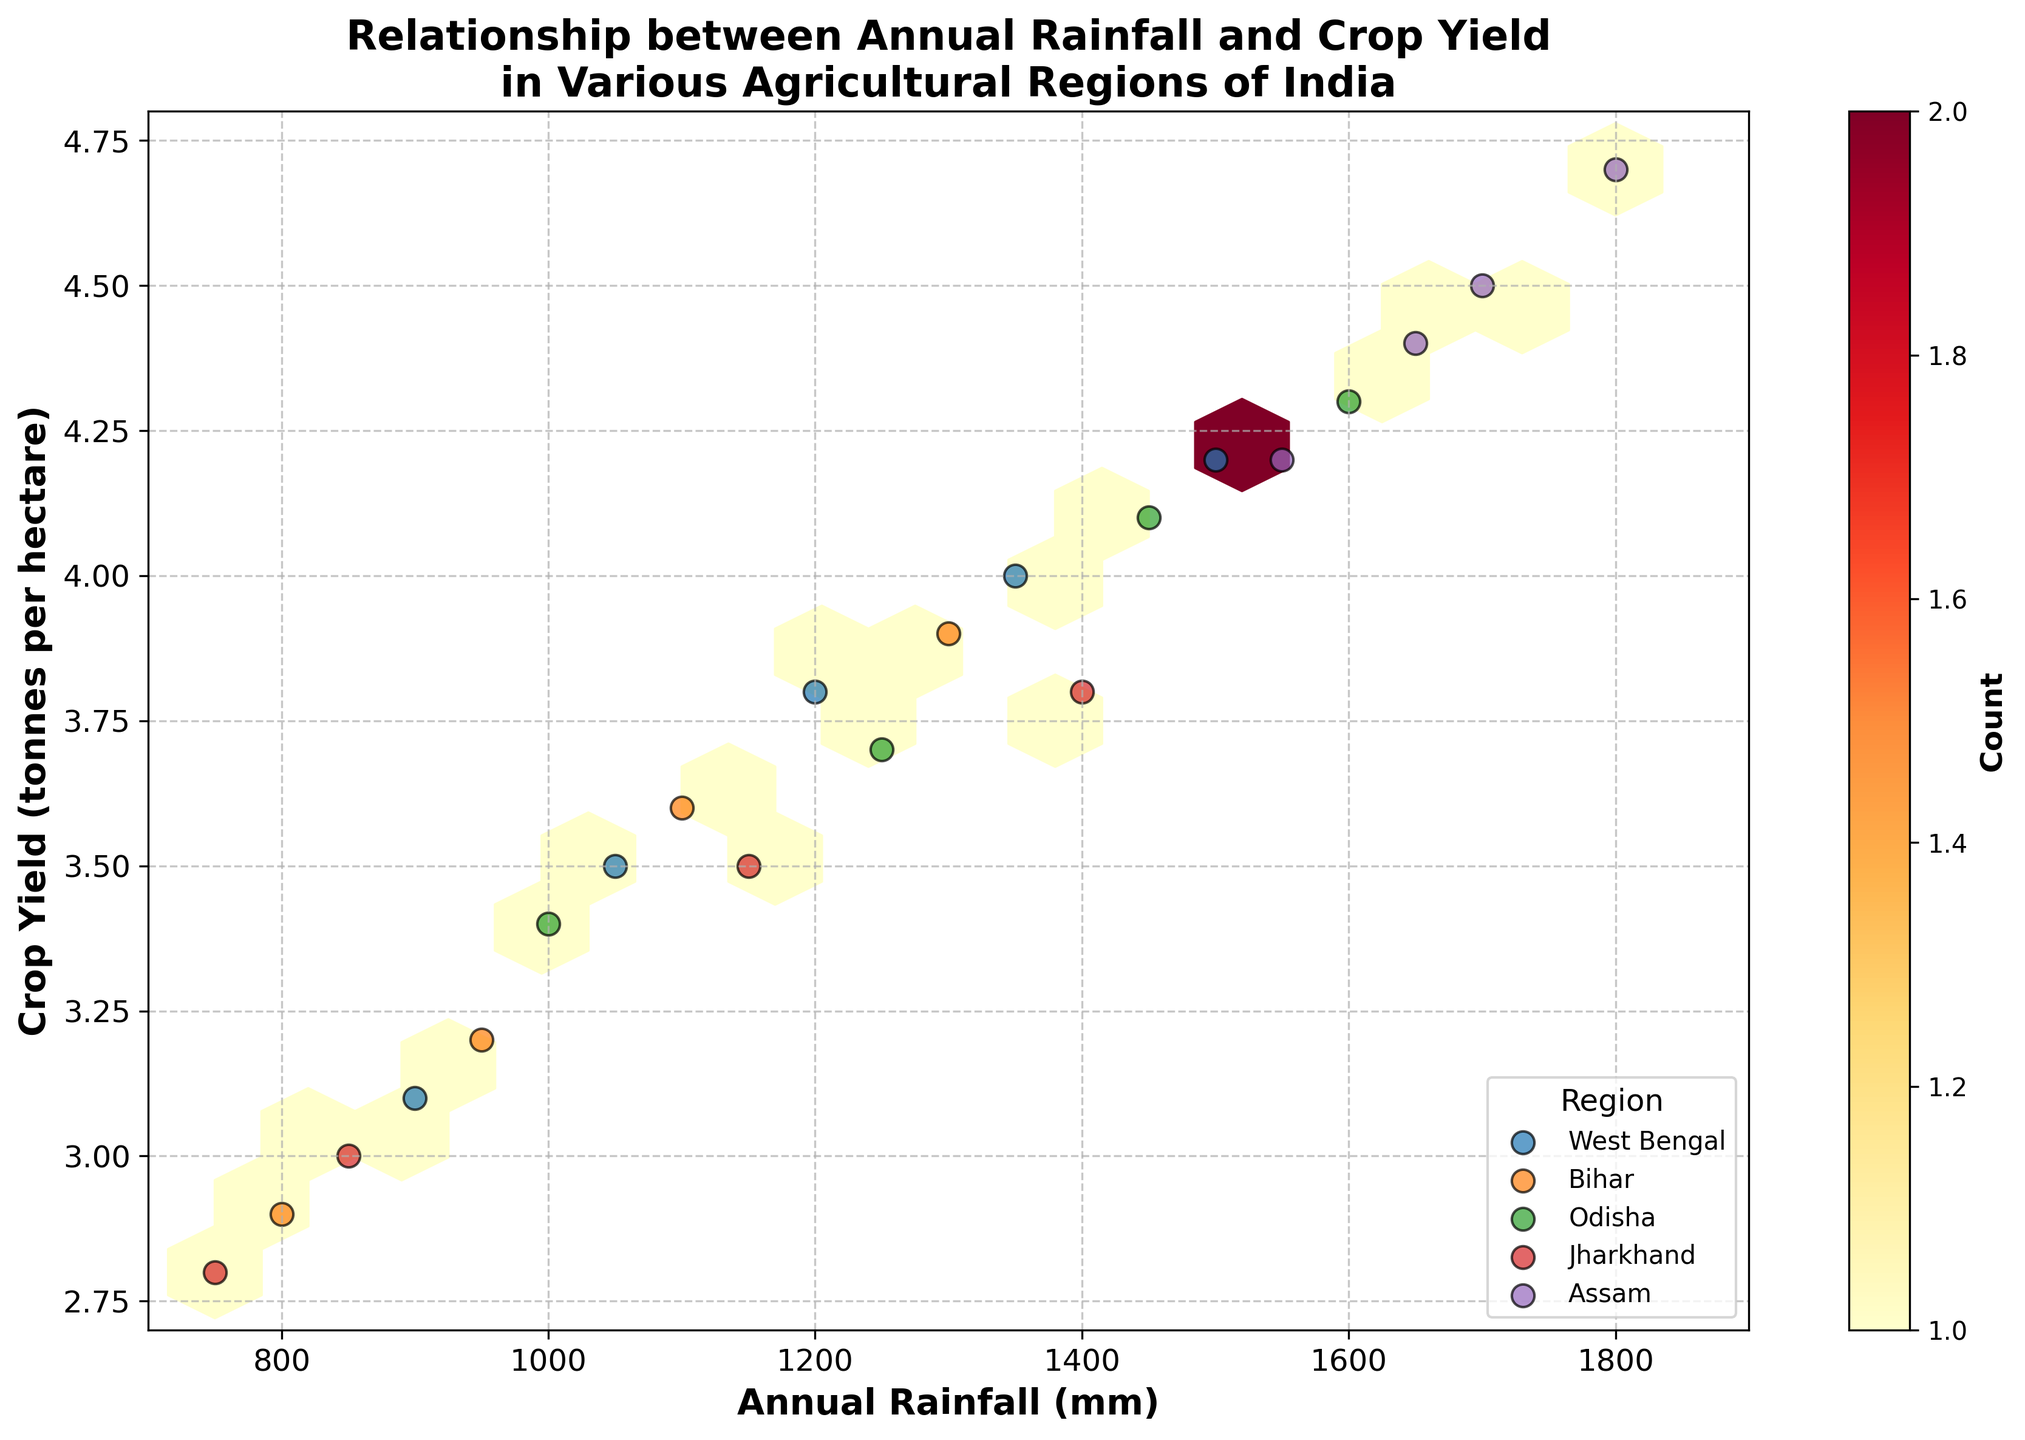What is the title of the plot? The title of the plot is displayed at the top in bold and large font. It summarizes the overall theme or subject of the plot.
Answer: Relationship between Annual Rainfall and Crop Yield in Various Agricultural Regions of India What does the color intensity represent in this plot? In a hexbin plot, the color intensity represents the density or count of data points within each hexagon. The legend indicates this with a color gradient changing from light to dark.
Answer: Count of data points What range of annual rainfall is covered in this plot? The x-axis of the plot represents the annual rainfall in millimeters, with tick marks indicating specific values. By observing these ticks, we can determine the range.
Answer: 700 mm to 1900 mm Which region seems to have the highest crop yield based on the scatter points added to the hexbin plot? By observing the scatter points on the hexbin plot, particularly looking at those with higher yield values on the y-axis, we can identify which region they belong to.
Answer: Assam What is the overall trend shown between annual rainfall and crop yield? Observing the distribution pattern of the hexagons and scatter points helps identify the general direction or relationship between the two variables on the plot.
Answer: Positive correlation How many unique regions are shown in the plot? The legend in the plot lists all the unique regions represented by different colored scatter points. By counting these entries, we determine the total number of unique regions.
Answer: 5 Which region has data points with the lowest amount of annual rainfall? To find the region with the lowest annual rainfall, look at the scatter points towards the leftmost side of the x-axis and identify the region they belong to based on their color and legend.
Answer: Jharkhand What is the maximum crop yield observed in the plot, and which region does it belong to? Locate the highest point on the y-axis representing crop yield, and then identify which region's scatter point it is based on its color and legend.
Answer: 4.7 tonnes per hectare, Assam Are there any regions where the crop yield and annual rainfall appear to be more variable compared to others? Variability can be assessed by observing the spread of scatter points for each region. Wider spread in both x-axis (rainfall) and y-axis (yield) indicates higher variability.
Answer: West Bengal and Odisha Does the plot show any significant outliers for crop yield or annual rainfall? Outliers can be identified by looking for scatter points that are significantly far from the main cluster of points or hexagons. These points will be isolated and distant from others.
Answer: No significant outliers 